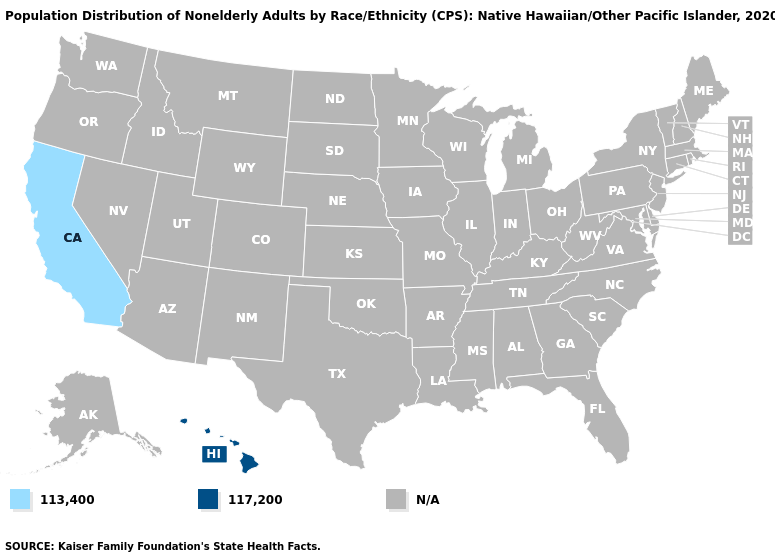What is the value of Missouri?
Keep it brief. N/A. Name the states that have a value in the range N/A?
Concise answer only. Alabama, Alaska, Arizona, Arkansas, Colorado, Connecticut, Delaware, Florida, Georgia, Idaho, Illinois, Indiana, Iowa, Kansas, Kentucky, Louisiana, Maine, Maryland, Massachusetts, Michigan, Minnesota, Mississippi, Missouri, Montana, Nebraska, Nevada, New Hampshire, New Jersey, New Mexico, New York, North Carolina, North Dakota, Ohio, Oklahoma, Oregon, Pennsylvania, Rhode Island, South Carolina, South Dakota, Tennessee, Texas, Utah, Vermont, Virginia, Washington, West Virginia, Wisconsin, Wyoming. Name the states that have a value in the range N/A?
Keep it brief. Alabama, Alaska, Arizona, Arkansas, Colorado, Connecticut, Delaware, Florida, Georgia, Idaho, Illinois, Indiana, Iowa, Kansas, Kentucky, Louisiana, Maine, Maryland, Massachusetts, Michigan, Minnesota, Mississippi, Missouri, Montana, Nebraska, Nevada, New Hampshire, New Jersey, New Mexico, New York, North Carolina, North Dakota, Ohio, Oklahoma, Oregon, Pennsylvania, Rhode Island, South Carolina, South Dakota, Tennessee, Texas, Utah, Vermont, Virginia, Washington, West Virginia, Wisconsin, Wyoming. What is the value of Indiana?
Be succinct. N/A. Name the states that have a value in the range 113,400?
Quick response, please. California. Name the states that have a value in the range N/A?
Be succinct. Alabama, Alaska, Arizona, Arkansas, Colorado, Connecticut, Delaware, Florida, Georgia, Idaho, Illinois, Indiana, Iowa, Kansas, Kentucky, Louisiana, Maine, Maryland, Massachusetts, Michigan, Minnesota, Mississippi, Missouri, Montana, Nebraska, Nevada, New Hampshire, New Jersey, New Mexico, New York, North Carolina, North Dakota, Ohio, Oklahoma, Oregon, Pennsylvania, Rhode Island, South Carolina, South Dakota, Tennessee, Texas, Utah, Vermont, Virginia, Washington, West Virginia, Wisconsin, Wyoming. Does the first symbol in the legend represent the smallest category?
Be succinct. Yes. What is the value of Kansas?
Keep it brief. N/A. What is the value of New Mexico?
Quick response, please. N/A. What is the value of Alaska?
Be succinct. N/A. What is the value of Florida?
Give a very brief answer. N/A. Does California have the highest value in the USA?
Keep it brief. No. Among the states that border Nevada , which have the lowest value?
Write a very short answer. California. 